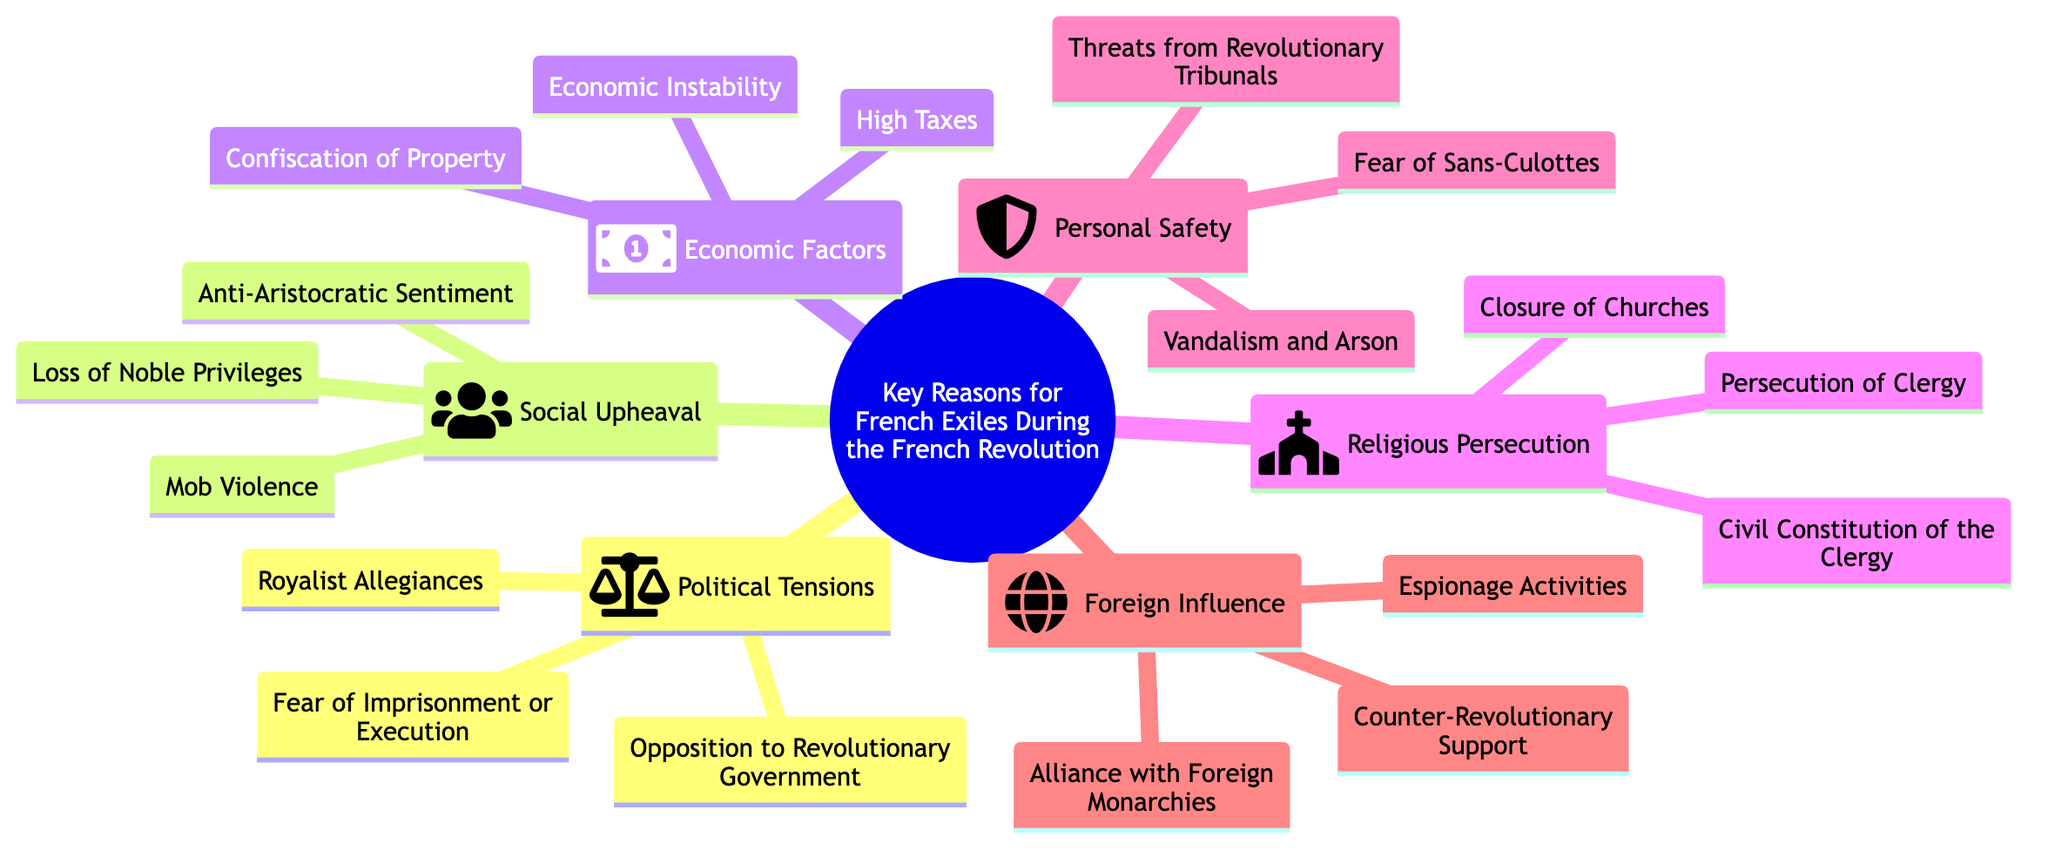What are the subtopics of the diagram? The diagram has six subtopics: Political Tensions, Social Upheaval, Economic Factors, Religious Persecution, Personal Safety, and Foreign Influence.
Answer: Political Tensions, Social Upheaval, Economic Factors, Religious Persecution, Personal Safety, Foreign Influence How many elements are listed under Economic Factors? The Economic Factors subtopic contains three elements: Confiscation of Property, Economic Instability, and High Taxes. Therefore, there are three elements listed.
Answer: 3 Which subtopic addresses the closure of churches? The closure of churches is related to the Religious Persecution subtopic, which includes elements such as Closure of Churches, Persecution of Clergy, and Civil Constitution of the Clergy.
Answer: Religious Persecution What is a reason for French exiles related to personal safety? The element "Fear of Sans-Culottes" under the Personal Safety subtopic indicates that fear for personal safety was a significant reason for French exiles.
Answer: Fear of Sans-Culottes Which subtopic includes the element "Royalist Allegiances"? The element "Royalist Allegiances" is part of the Political Tensions subtopic, which mentions aspects related to opposition against the revolutionary government and associated fears.
Answer: Political Tensions Identify a foreign influence mentioned in the diagram. The subtopic Foreign Influence includes "Alliance with Foreign Monarchies," which describes one of the factors contributing to French exiles during the Revolution.
Answer: Alliance with Foreign Monarchies How many elements are listed under Social Upheaval? The Social Upheaval subtopic has three elements: Loss of Noble Privileges, Anti-Aristocratic Sentiment, and Mob Violence, indicating significant societal changes during the Revolution.
Answer: 3 Which subtopic includes both economic instability and high taxes? Both "Economic Instability" and "High Taxes" are elements listed under the Economic Factors subtopic, which addresses financial issues faced during the Revolution.
Answer: Economic Factors What type of violence is indicated in the Personal Safety subtopic? The element "Vandalism and Arson" under the Personal Safety subtopic indicates a form of violence linked to personal safety concerns during the Revolution.
Answer: Vandalism and Arson 